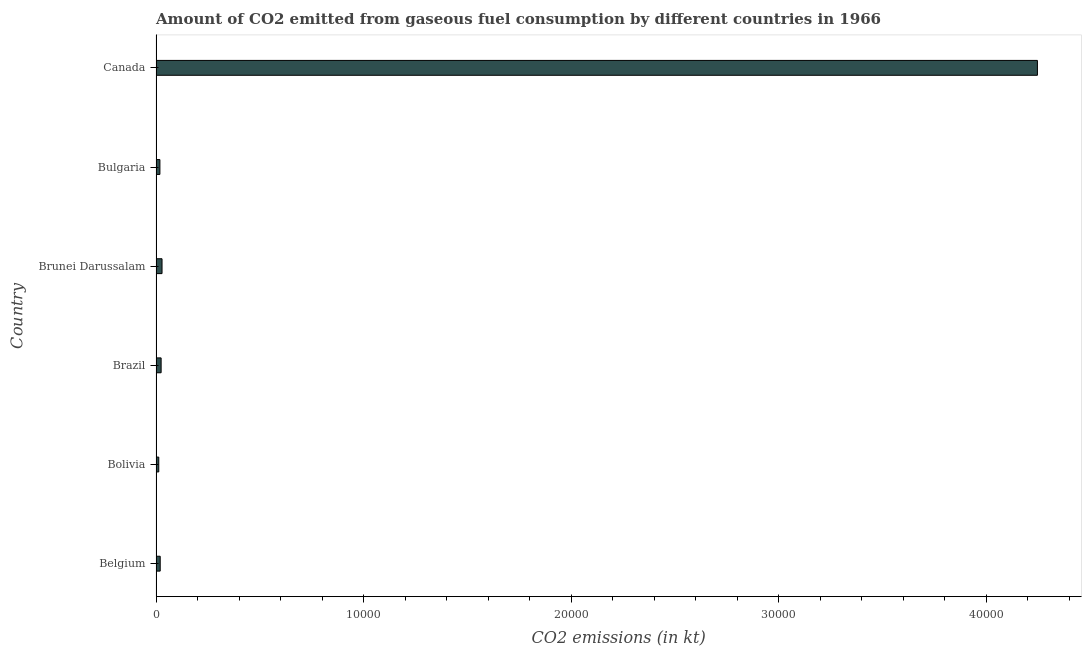Does the graph contain grids?
Provide a short and direct response. No. What is the title of the graph?
Keep it short and to the point. Amount of CO2 emitted from gaseous fuel consumption by different countries in 1966. What is the label or title of the X-axis?
Make the answer very short. CO2 emissions (in kt). What is the co2 emissions from gaseous fuel consumption in Brazil?
Provide a succinct answer. 245.69. Across all countries, what is the maximum co2 emissions from gaseous fuel consumption?
Your answer should be compact. 4.25e+04. Across all countries, what is the minimum co2 emissions from gaseous fuel consumption?
Make the answer very short. 132.01. In which country was the co2 emissions from gaseous fuel consumption minimum?
Ensure brevity in your answer.  Bolivia. What is the sum of the co2 emissions from gaseous fuel consumption?
Offer a very short reply. 4.35e+04. What is the difference between the co2 emissions from gaseous fuel consumption in Bolivia and Bulgaria?
Make the answer very short. -55.01. What is the average co2 emissions from gaseous fuel consumption per country?
Make the answer very short. 7252.1. What is the median co2 emissions from gaseous fuel consumption?
Your answer should be compact. 223.69. What is the ratio of the co2 emissions from gaseous fuel consumption in Bolivia to that in Bulgaria?
Give a very brief answer. 0.71. Is the co2 emissions from gaseous fuel consumption in Bolivia less than that in Canada?
Your response must be concise. Yes. Is the difference between the co2 emissions from gaseous fuel consumption in Bolivia and Brunei Darussalam greater than the difference between any two countries?
Keep it short and to the point. No. What is the difference between the highest and the second highest co2 emissions from gaseous fuel consumption?
Keep it short and to the point. 4.22e+04. What is the difference between the highest and the lowest co2 emissions from gaseous fuel consumption?
Offer a very short reply. 4.23e+04. How many bars are there?
Make the answer very short. 6. What is the difference between two consecutive major ticks on the X-axis?
Make the answer very short. 10000. Are the values on the major ticks of X-axis written in scientific E-notation?
Make the answer very short. No. What is the CO2 emissions (in kt) in Belgium?
Offer a very short reply. 201.69. What is the CO2 emissions (in kt) in Bolivia?
Your answer should be very brief. 132.01. What is the CO2 emissions (in kt) of Brazil?
Give a very brief answer. 245.69. What is the CO2 emissions (in kt) in Brunei Darussalam?
Your answer should be compact. 289.69. What is the CO2 emissions (in kt) in Bulgaria?
Offer a very short reply. 187.02. What is the CO2 emissions (in kt) of Canada?
Your answer should be very brief. 4.25e+04. What is the difference between the CO2 emissions (in kt) in Belgium and Bolivia?
Give a very brief answer. 69.67. What is the difference between the CO2 emissions (in kt) in Belgium and Brazil?
Ensure brevity in your answer.  -44. What is the difference between the CO2 emissions (in kt) in Belgium and Brunei Darussalam?
Ensure brevity in your answer.  -88.01. What is the difference between the CO2 emissions (in kt) in Belgium and Bulgaria?
Your answer should be very brief. 14.67. What is the difference between the CO2 emissions (in kt) in Belgium and Canada?
Your answer should be compact. -4.23e+04. What is the difference between the CO2 emissions (in kt) in Bolivia and Brazil?
Your answer should be compact. -113.68. What is the difference between the CO2 emissions (in kt) in Bolivia and Brunei Darussalam?
Provide a succinct answer. -157.68. What is the difference between the CO2 emissions (in kt) in Bolivia and Bulgaria?
Keep it short and to the point. -55.01. What is the difference between the CO2 emissions (in kt) in Bolivia and Canada?
Provide a short and direct response. -4.23e+04. What is the difference between the CO2 emissions (in kt) in Brazil and Brunei Darussalam?
Your answer should be compact. -44. What is the difference between the CO2 emissions (in kt) in Brazil and Bulgaria?
Provide a succinct answer. 58.67. What is the difference between the CO2 emissions (in kt) in Brazil and Canada?
Give a very brief answer. -4.22e+04. What is the difference between the CO2 emissions (in kt) in Brunei Darussalam and Bulgaria?
Offer a very short reply. 102.68. What is the difference between the CO2 emissions (in kt) in Brunei Darussalam and Canada?
Provide a short and direct response. -4.22e+04. What is the difference between the CO2 emissions (in kt) in Bulgaria and Canada?
Make the answer very short. -4.23e+04. What is the ratio of the CO2 emissions (in kt) in Belgium to that in Bolivia?
Give a very brief answer. 1.53. What is the ratio of the CO2 emissions (in kt) in Belgium to that in Brazil?
Keep it short and to the point. 0.82. What is the ratio of the CO2 emissions (in kt) in Belgium to that in Brunei Darussalam?
Offer a very short reply. 0.7. What is the ratio of the CO2 emissions (in kt) in Belgium to that in Bulgaria?
Make the answer very short. 1.08. What is the ratio of the CO2 emissions (in kt) in Belgium to that in Canada?
Make the answer very short. 0.01. What is the ratio of the CO2 emissions (in kt) in Bolivia to that in Brazil?
Offer a very short reply. 0.54. What is the ratio of the CO2 emissions (in kt) in Bolivia to that in Brunei Darussalam?
Offer a terse response. 0.46. What is the ratio of the CO2 emissions (in kt) in Bolivia to that in Bulgaria?
Give a very brief answer. 0.71. What is the ratio of the CO2 emissions (in kt) in Bolivia to that in Canada?
Your response must be concise. 0. What is the ratio of the CO2 emissions (in kt) in Brazil to that in Brunei Darussalam?
Make the answer very short. 0.85. What is the ratio of the CO2 emissions (in kt) in Brazil to that in Bulgaria?
Keep it short and to the point. 1.31. What is the ratio of the CO2 emissions (in kt) in Brazil to that in Canada?
Offer a terse response. 0.01. What is the ratio of the CO2 emissions (in kt) in Brunei Darussalam to that in Bulgaria?
Keep it short and to the point. 1.55. What is the ratio of the CO2 emissions (in kt) in Brunei Darussalam to that in Canada?
Your answer should be compact. 0.01. What is the ratio of the CO2 emissions (in kt) in Bulgaria to that in Canada?
Provide a short and direct response. 0. 